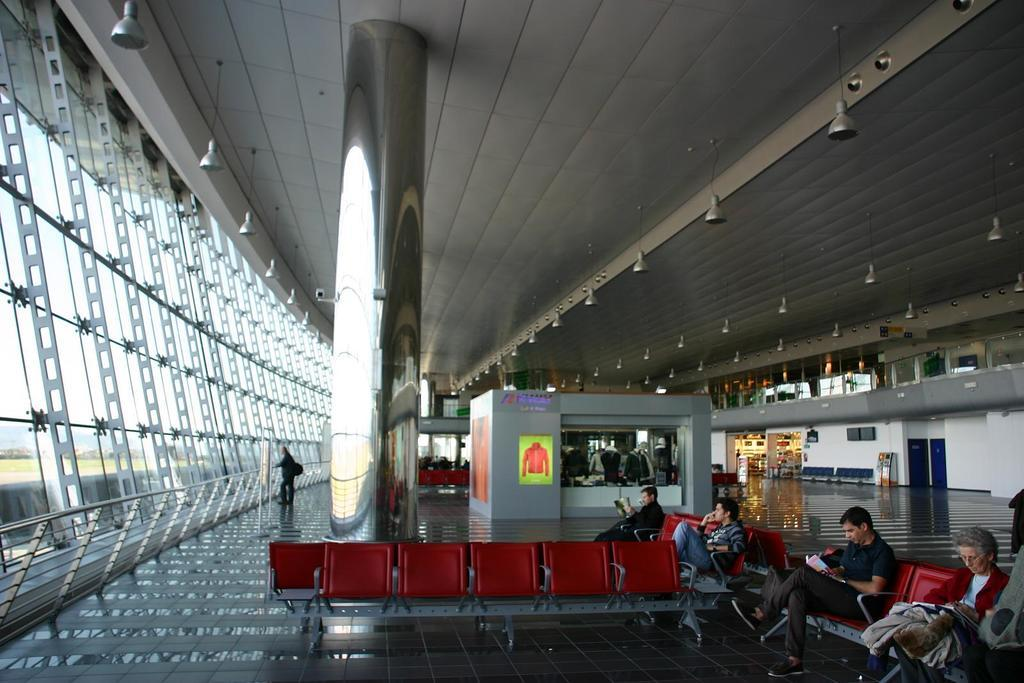What are the people in the image doing? The people in the image are sitting on chairs. What can be found in the shop in the image? There are clothes in the shop in the image. What is on top of the building in the image? There are lightings on the top of the building in the image. What type of stew is being served in the image? There is no stew present in the image. What material is used to make the lace curtains in the image? There are no lace curtains present in the image. 